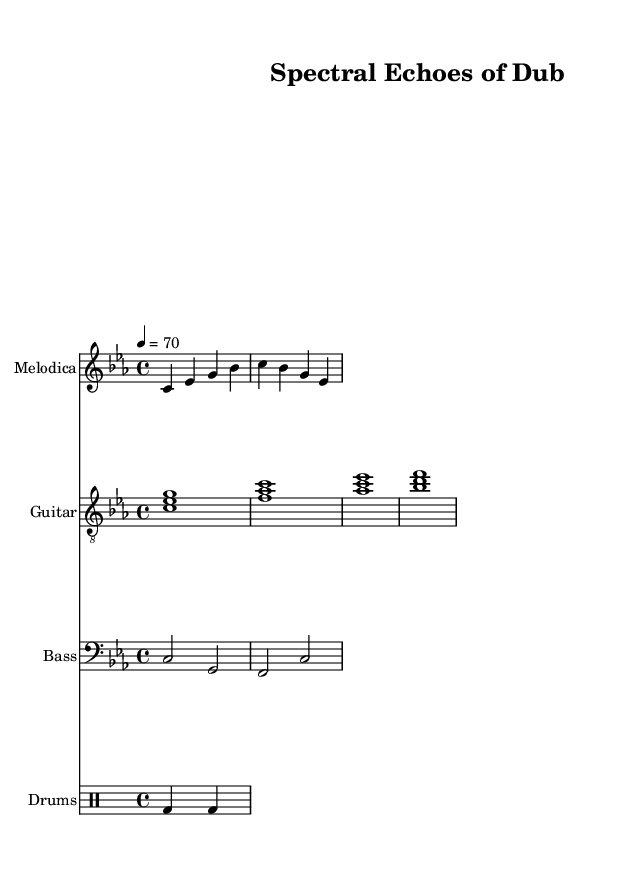What is the key signature of this music? The key signature is C minor, indicated by the flats in the key signature area. The presence of three flats suggests C minor specifically.
Answer: C minor What is the time signature of this piece? The time signature is 4/4, which is stated clearly at the beginning of the score. This means there are four beats in a measure, and each beat is a quarter note.
Answer: 4/4 What is the tempo marking for this composition? The tempo marking indicates a speed of 70 beats per minute, shown in the tempo line at the beginning of the score. This gives a moderate pace suitable for introspective meditation.
Answer: 70 How long does the bass section play in the first measure? The bass plays for a value of 2 beats in the first measure, as indicated by the half note on C followed by the half note on G in a 4/4 time signature.
Answer: 2 beats What instrument plays the melody in this score? The melodica is the instrument designated to play the melody, as indicated in the header for the first staff at the beginning.
Answer: Melodica Describe the primary rhythmic pattern used in the drums. The rhythmic pattern in the drum section consists of a kick drum note followed by a rest, repeating this pattern, which typically characterizes reggae rhythms due to its laid-back feel.
Answer: Kick and rest pattern How many measures are in the melodica section? The melodica plays for a total of two measures as indicated by the two lines of music under the staff, each consisting of four beats.
Answer: 2 measures 